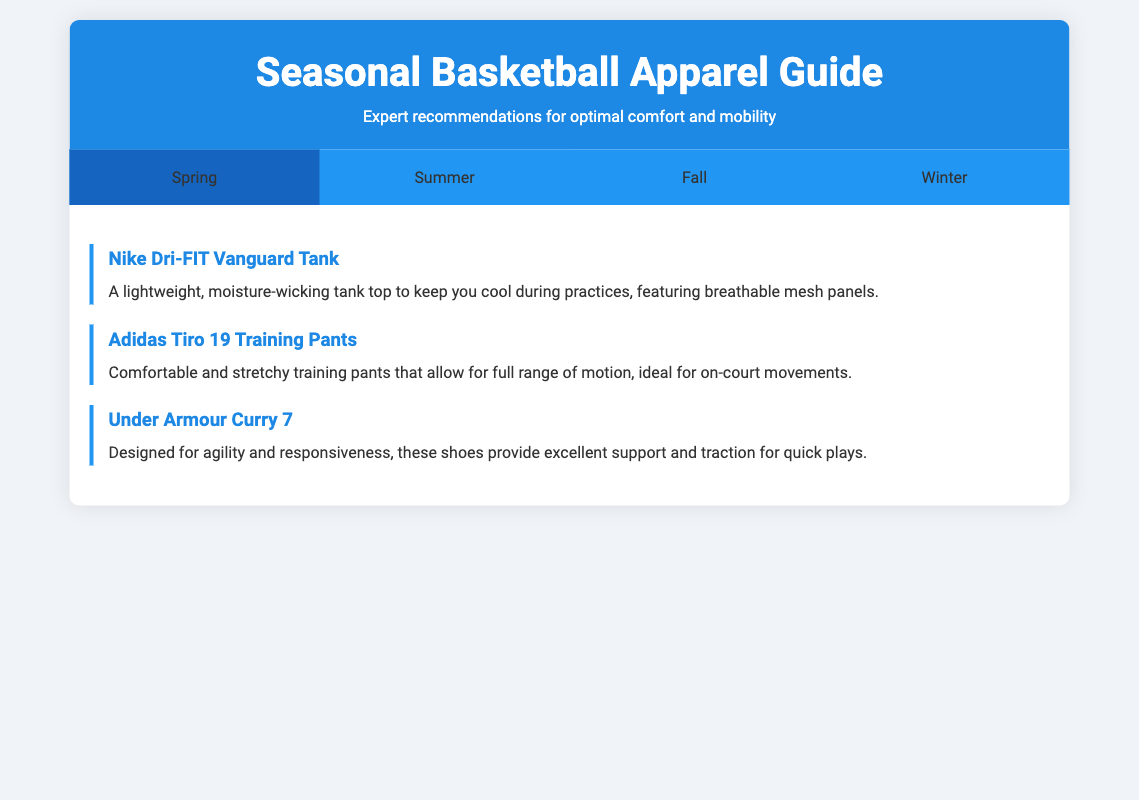What is the lightweight tank top recommended for spring? The document lists the Nike Dri-FIT Vanguard Tank as the lightweight tank top for spring.
Answer: Nike Dri-FIT Vanguard Tank Which brand's shoes are designed for agility and responsiveness in spring? The Under Armour Curry 7 shoes are specifically recommended for agility and responsiveness in the spring section of the document.
Answer: Under Armour What type of pants is suggested for summer training? The Lululemon Pace Breaker Shorts are mentioned as lightweight shorts designed for summer training.
Answer: Lululemon Pace Breaker Shorts What apparel is recommended for cooler temperatures in fall? The Under Armour ColdGear Compression Mock is highlighted as ideal for cooler temperatures in the fall section.
Answer: Under Armour ColdGear Compression Mock Which shoes are engineered for winter conditions? The Asics Gel-Quantum 360 5 shoes are specified as being engineered for winter conditions.
Answer: Asics Gel-Quantum 360 5 How many seasons are covered in the seasonal apparel guide? The document includes recommendations for four seasons: spring, summer, fall, and winter.
Answer: Four What is the recommended apparel for winter workouts? The Nike Therma Training Pants are recommended for winter workouts.
Answer: Nike Therma Training Pants Which tank top features breathable mesh panels? The Nike Dri-FIT Vanguard Tank features breathable mesh panels for comfort.
Answer: Nike Dri-FIT Vanguard Tank What are the main attributes of the Puma Performance Tee? The Puma Performance Tee is described as a short-sleeve performance tee offering breathability for hot training sessions.
Answer: Breathability 